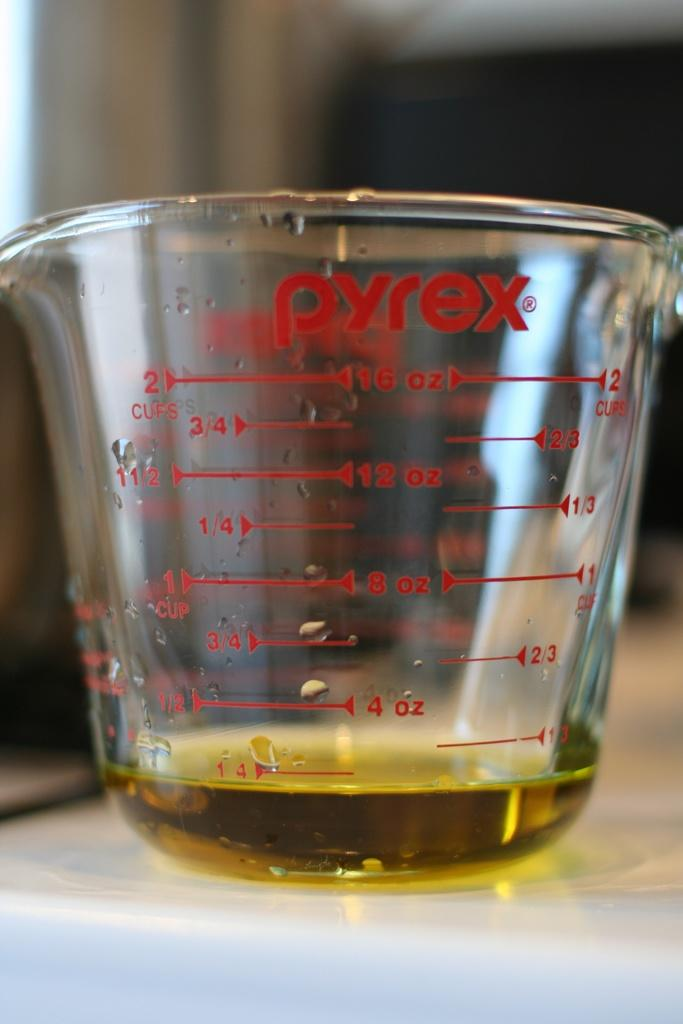Provide a one-sentence caption for the provided image. Pyrex measuring cup that measures cups and ounces. 